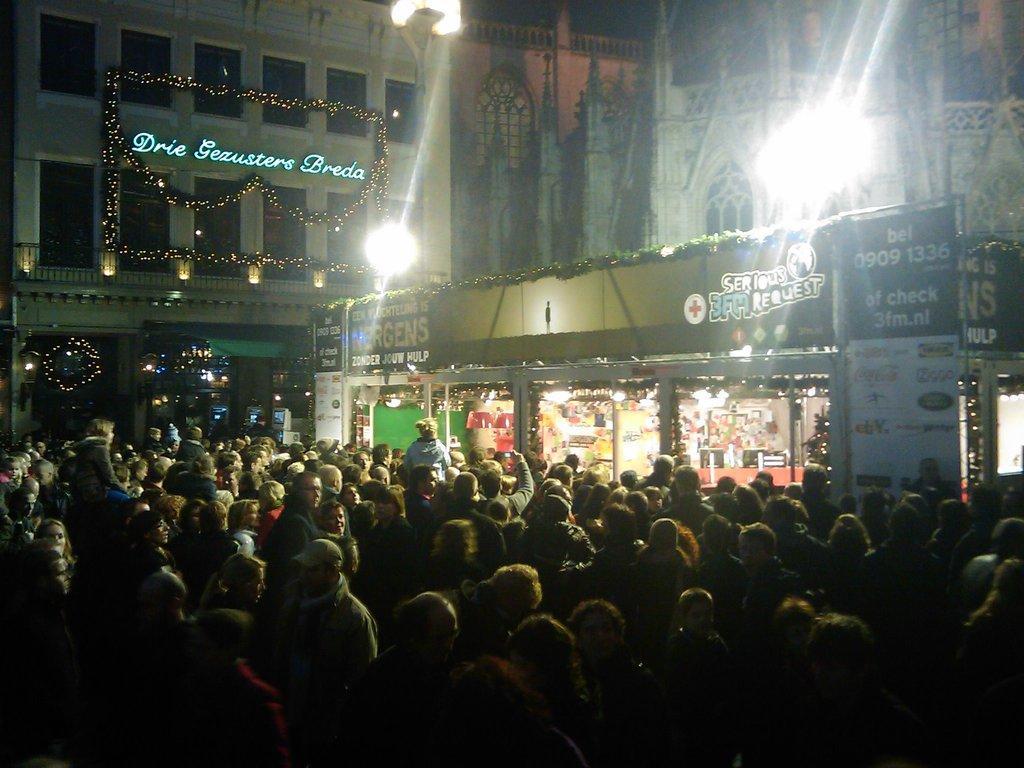Please provide a concise description of this image. In this image I can see a group of people, few buildings, windows, lights, stores and boards. 